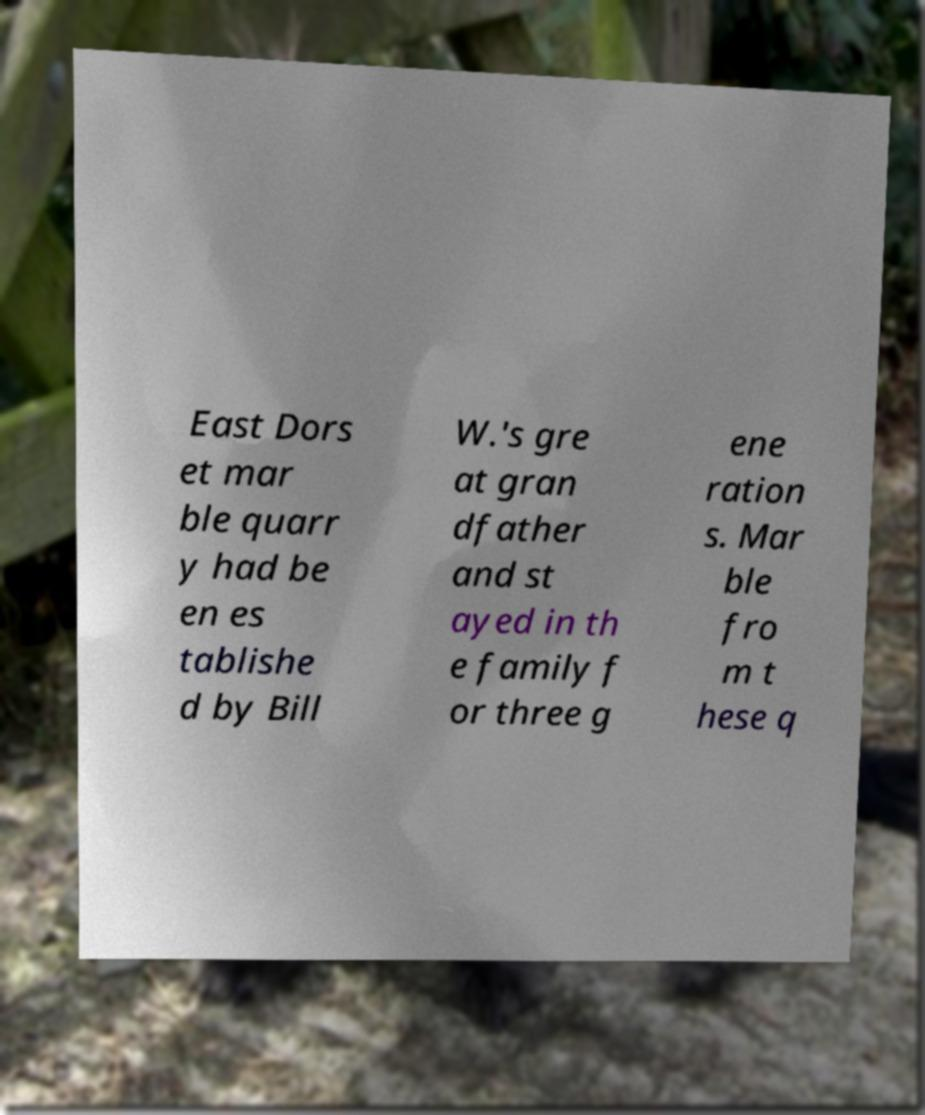I need the written content from this picture converted into text. Can you do that? East Dors et mar ble quarr y had be en es tablishe d by Bill W.'s gre at gran dfather and st ayed in th e family f or three g ene ration s. Mar ble fro m t hese q 